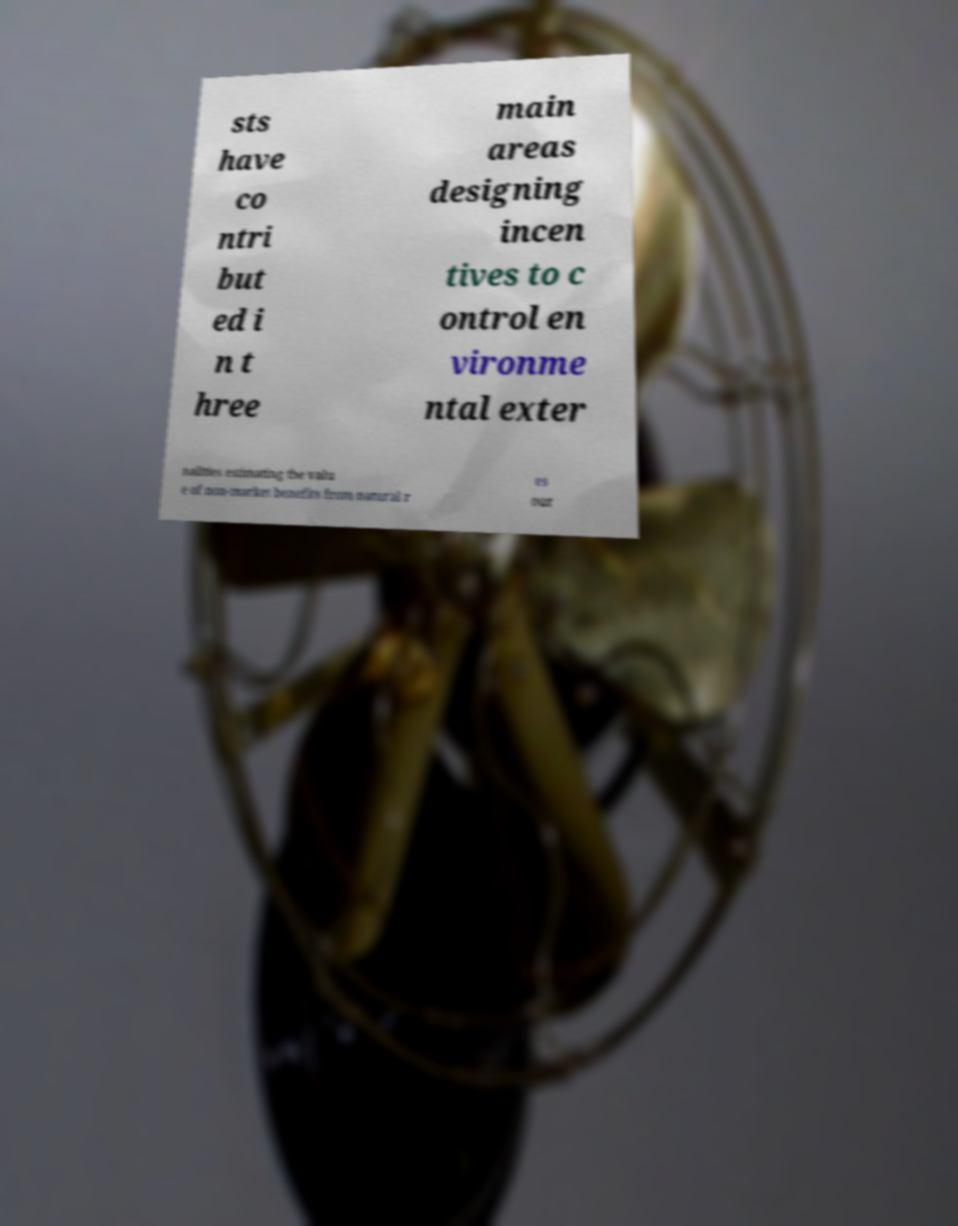Please read and relay the text visible in this image. What does it say? sts have co ntri but ed i n t hree main areas designing incen tives to c ontrol en vironme ntal exter nalities estimating the valu e of non-market benefits from natural r es our 